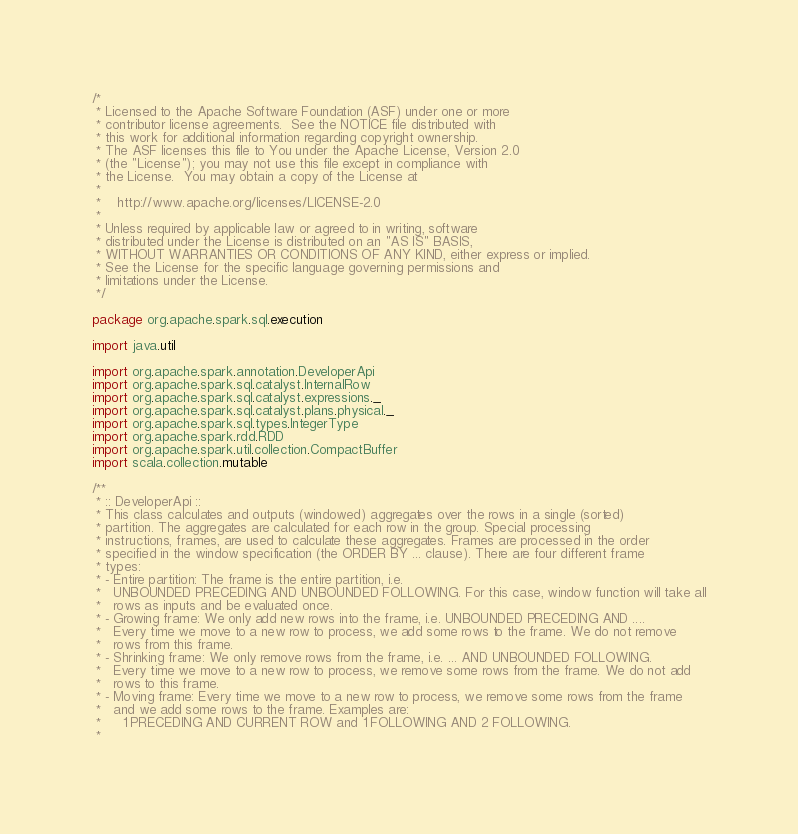<code> <loc_0><loc_0><loc_500><loc_500><_Scala_>/*
 * Licensed to the Apache Software Foundation (ASF) under one or more
 * contributor license agreements.  See the NOTICE file distributed with
 * this work for additional information regarding copyright ownership.
 * The ASF licenses this file to You under the Apache License, Version 2.0
 * (the "License"); you may not use this file except in compliance with
 * the License.  You may obtain a copy of the License at
 *
 *    http://www.apache.org/licenses/LICENSE-2.0
 *
 * Unless required by applicable law or agreed to in writing, software
 * distributed under the License is distributed on an "AS IS" BASIS,
 * WITHOUT WARRANTIES OR CONDITIONS OF ANY KIND, either express or implied.
 * See the License for the specific language governing permissions and
 * limitations under the License.
 */

package org.apache.spark.sql.execution

import java.util

import org.apache.spark.annotation.DeveloperApi
import org.apache.spark.sql.catalyst.InternalRow
import org.apache.spark.sql.catalyst.expressions._
import org.apache.spark.sql.catalyst.plans.physical._
import org.apache.spark.sql.types.IntegerType
import org.apache.spark.rdd.RDD
import org.apache.spark.util.collection.CompactBuffer
import scala.collection.mutable

/**
 * :: DeveloperApi ::
 * This class calculates and outputs (windowed) aggregates over the rows in a single (sorted)
 * partition. The aggregates are calculated for each row in the group. Special processing
 * instructions, frames, are used to calculate these aggregates. Frames are processed in the order
 * specified in the window specification (the ORDER BY ... clause). There are four different frame
 * types:
 * - Entire partition: The frame is the entire partition, i.e.
 *   UNBOUNDED PRECEDING AND UNBOUNDED FOLLOWING. For this case, window function will take all
 *   rows as inputs and be evaluated once.
 * - Growing frame: We only add new rows into the frame, i.e. UNBOUNDED PRECEDING AND ....
 *   Every time we move to a new row to process, we add some rows to the frame. We do not remove
 *   rows from this frame.
 * - Shrinking frame: We only remove rows from the frame, i.e. ... AND UNBOUNDED FOLLOWING.
 *   Every time we move to a new row to process, we remove some rows from the frame. We do not add
 *   rows to this frame.
 * - Moving frame: Every time we move to a new row to process, we remove some rows from the frame
 *   and we add some rows to the frame. Examples are:
 *     1 PRECEDING AND CURRENT ROW and 1 FOLLOWING AND 2 FOLLOWING.
 *</code> 